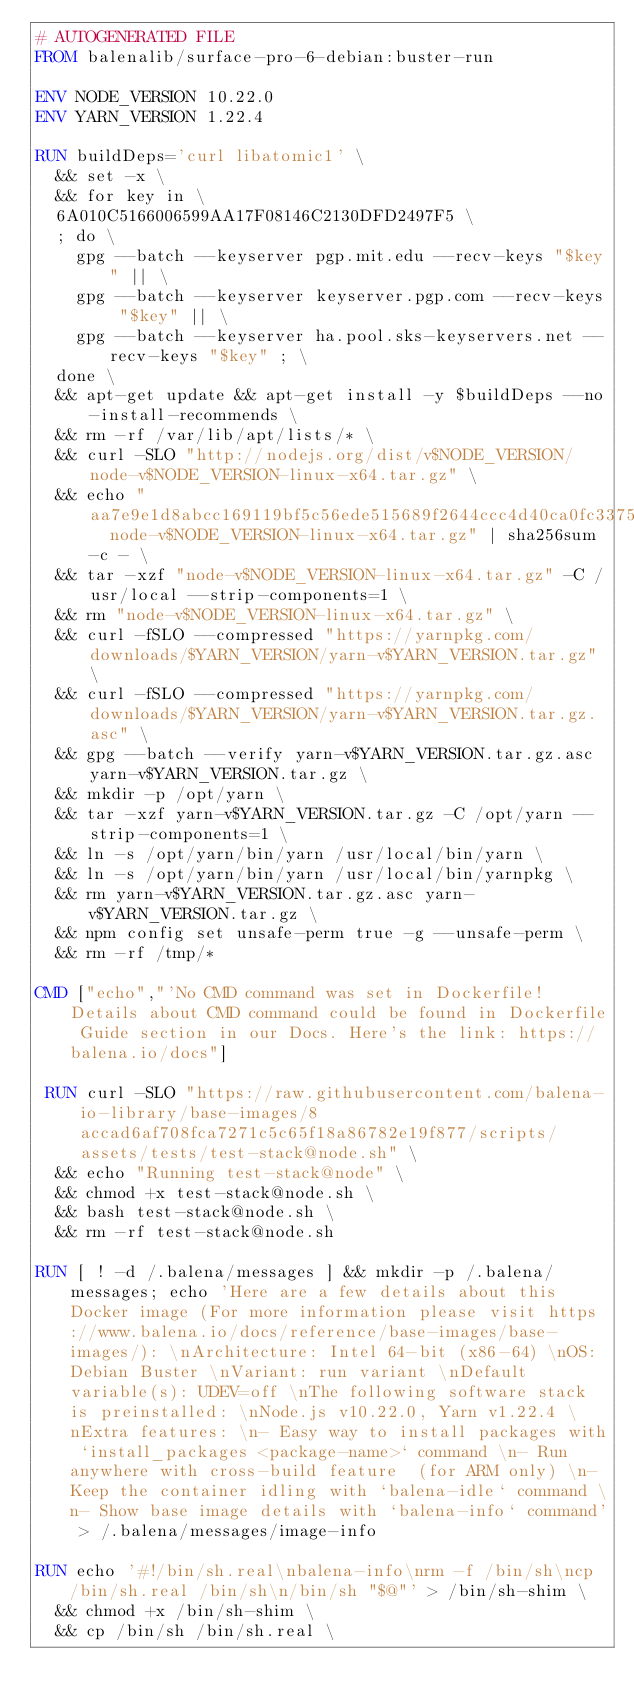Convert code to text. <code><loc_0><loc_0><loc_500><loc_500><_Dockerfile_># AUTOGENERATED FILE
FROM balenalib/surface-pro-6-debian:buster-run

ENV NODE_VERSION 10.22.0
ENV YARN_VERSION 1.22.4

RUN buildDeps='curl libatomic1' \
	&& set -x \
	&& for key in \
	6A010C5166006599AA17F08146C2130DFD2497F5 \
	; do \
		gpg --batch --keyserver pgp.mit.edu --recv-keys "$key" || \
		gpg --batch --keyserver keyserver.pgp.com --recv-keys "$key" || \
		gpg --batch --keyserver ha.pool.sks-keyservers.net --recv-keys "$key" ; \
	done \
	&& apt-get update && apt-get install -y $buildDeps --no-install-recommends \
	&& rm -rf /var/lib/apt/lists/* \
	&& curl -SLO "http://nodejs.org/dist/v$NODE_VERSION/node-v$NODE_VERSION-linux-x64.tar.gz" \
	&& echo "aa7e9e1d8abcc169119bf5c56ede515689f2644ccc4d40ca0fc33756a3deb1f7  node-v$NODE_VERSION-linux-x64.tar.gz" | sha256sum -c - \
	&& tar -xzf "node-v$NODE_VERSION-linux-x64.tar.gz" -C /usr/local --strip-components=1 \
	&& rm "node-v$NODE_VERSION-linux-x64.tar.gz" \
	&& curl -fSLO --compressed "https://yarnpkg.com/downloads/$YARN_VERSION/yarn-v$YARN_VERSION.tar.gz" \
	&& curl -fSLO --compressed "https://yarnpkg.com/downloads/$YARN_VERSION/yarn-v$YARN_VERSION.tar.gz.asc" \
	&& gpg --batch --verify yarn-v$YARN_VERSION.tar.gz.asc yarn-v$YARN_VERSION.tar.gz \
	&& mkdir -p /opt/yarn \
	&& tar -xzf yarn-v$YARN_VERSION.tar.gz -C /opt/yarn --strip-components=1 \
	&& ln -s /opt/yarn/bin/yarn /usr/local/bin/yarn \
	&& ln -s /opt/yarn/bin/yarn /usr/local/bin/yarnpkg \
	&& rm yarn-v$YARN_VERSION.tar.gz.asc yarn-v$YARN_VERSION.tar.gz \
	&& npm config set unsafe-perm true -g --unsafe-perm \
	&& rm -rf /tmp/*

CMD ["echo","'No CMD command was set in Dockerfile! Details about CMD command could be found in Dockerfile Guide section in our Docs. Here's the link: https://balena.io/docs"]

 RUN curl -SLO "https://raw.githubusercontent.com/balena-io-library/base-images/8accad6af708fca7271c5c65f18a86782e19f877/scripts/assets/tests/test-stack@node.sh" \
  && echo "Running test-stack@node" \
  && chmod +x test-stack@node.sh \
  && bash test-stack@node.sh \
  && rm -rf test-stack@node.sh 

RUN [ ! -d /.balena/messages ] && mkdir -p /.balena/messages; echo 'Here are a few details about this Docker image (For more information please visit https://www.balena.io/docs/reference/base-images/base-images/): \nArchitecture: Intel 64-bit (x86-64) \nOS: Debian Buster \nVariant: run variant \nDefault variable(s): UDEV=off \nThe following software stack is preinstalled: \nNode.js v10.22.0, Yarn v1.22.4 \nExtra features: \n- Easy way to install packages with `install_packages <package-name>` command \n- Run anywhere with cross-build feature  (for ARM only) \n- Keep the container idling with `balena-idle` command \n- Show base image details with `balena-info` command' > /.balena/messages/image-info

RUN echo '#!/bin/sh.real\nbalena-info\nrm -f /bin/sh\ncp /bin/sh.real /bin/sh\n/bin/sh "$@"' > /bin/sh-shim \
	&& chmod +x /bin/sh-shim \
	&& cp /bin/sh /bin/sh.real \</code> 